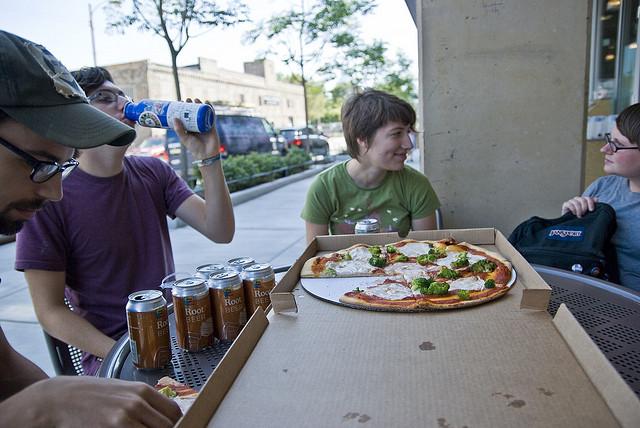Are they sharing one pizza?
Short answer required. Yes. What color shirt is the person wearing who is drinking a beverage?
Answer briefly. Purple. How many are wearing glasses?
Quick response, please. 3. 